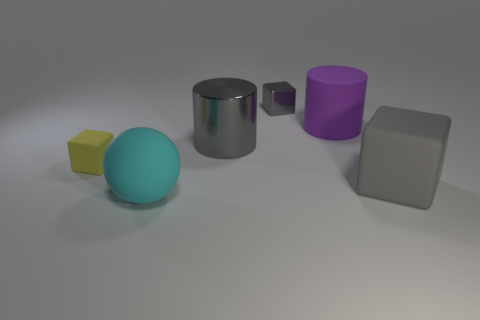What can you infer about the size relationship between these objects? The cyan ball appears to be the largest object, followed by the grey block and silver cylinder, which seem to have a similar diameter but the cylinder is taller. The purple cube is smaller than the aforementioned objects, and the yellow cube is the smallest. 